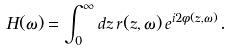<formula> <loc_0><loc_0><loc_500><loc_500>H ( \omega ) = \int _ { 0 } ^ { \infty } d z \, r ( z , \omega ) \, e ^ { i 2 \phi ( z , \omega ) } .</formula> 